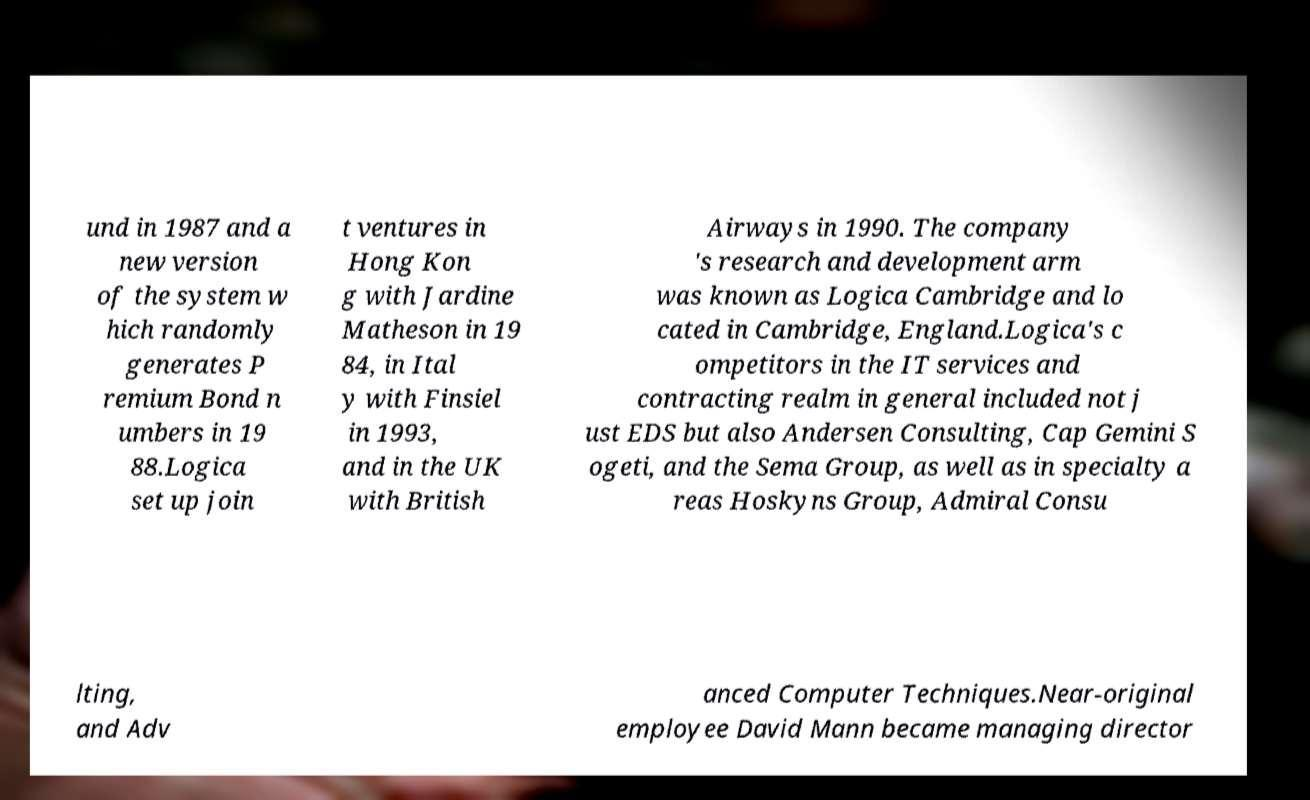Could you assist in decoding the text presented in this image and type it out clearly? und in 1987 and a new version of the system w hich randomly generates P remium Bond n umbers in 19 88.Logica set up join t ventures in Hong Kon g with Jardine Matheson in 19 84, in Ital y with Finsiel in 1993, and in the UK with British Airways in 1990. The company 's research and development arm was known as Logica Cambridge and lo cated in Cambridge, England.Logica's c ompetitors in the IT services and contracting realm in general included not j ust EDS but also Andersen Consulting, Cap Gemini S ogeti, and the Sema Group, as well as in specialty a reas Hoskyns Group, Admiral Consu lting, and Adv anced Computer Techniques.Near-original employee David Mann became managing director 